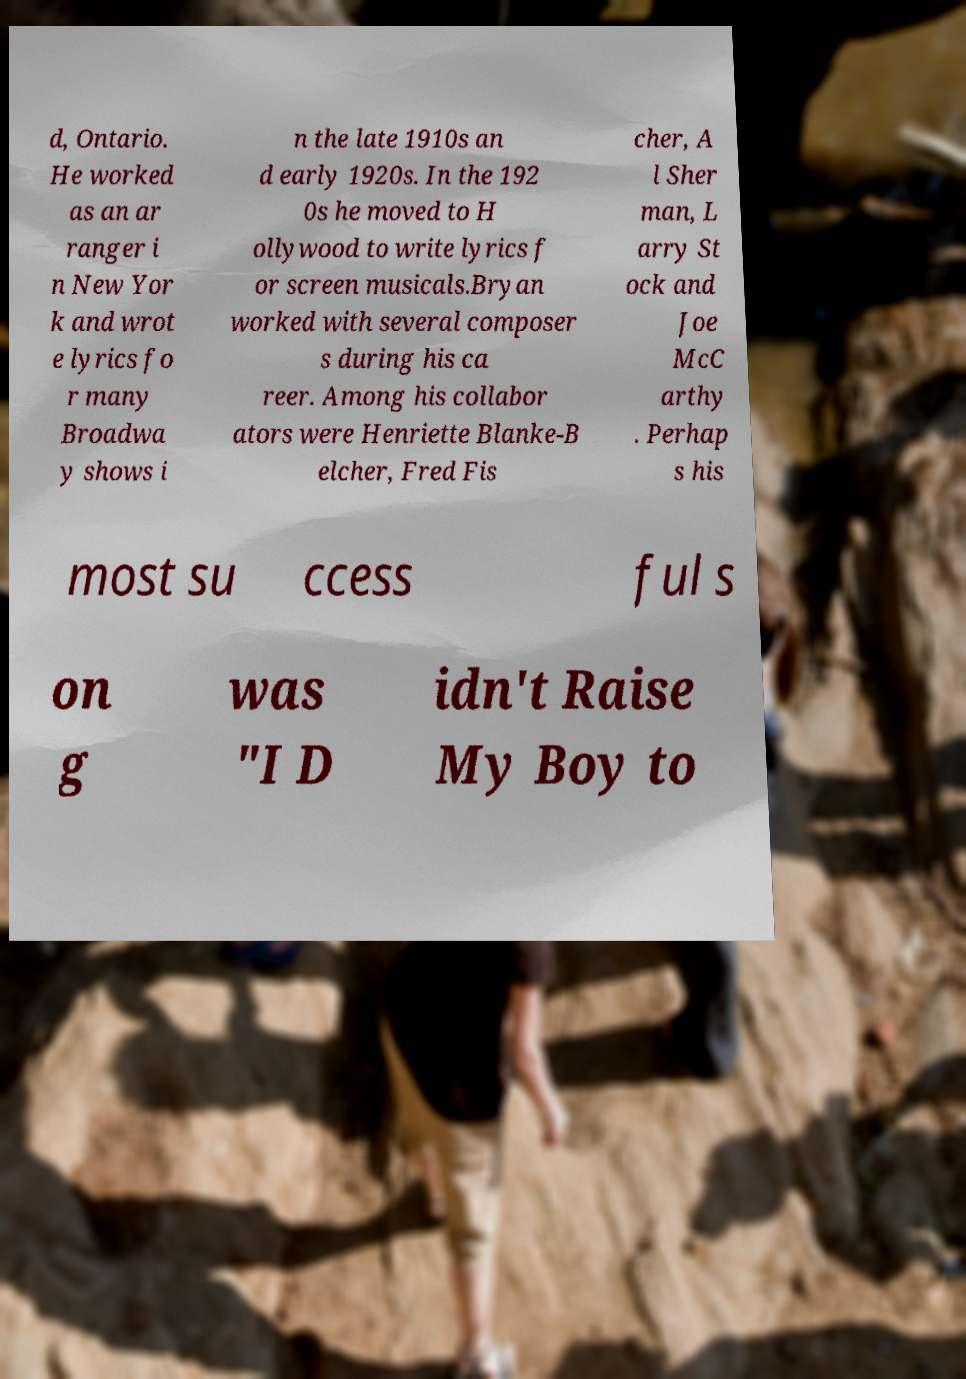What messages or text are displayed in this image? I need them in a readable, typed format. d, Ontario. He worked as an ar ranger i n New Yor k and wrot e lyrics fo r many Broadwa y shows i n the late 1910s an d early 1920s. In the 192 0s he moved to H ollywood to write lyrics f or screen musicals.Bryan worked with several composer s during his ca reer. Among his collabor ators were Henriette Blanke-B elcher, Fred Fis cher, A l Sher man, L arry St ock and Joe McC arthy . Perhap s his most su ccess ful s on g was "I D idn't Raise My Boy to 